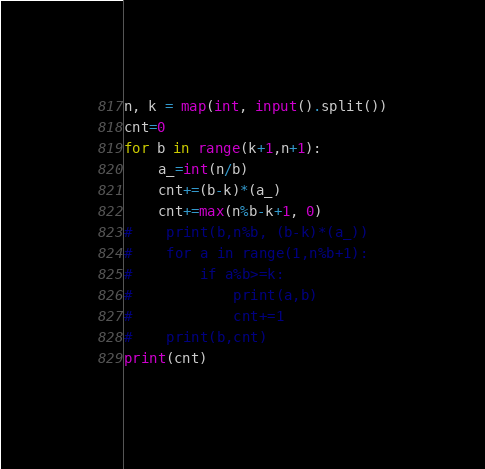<code> <loc_0><loc_0><loc_500><loc_500><_Python_>n, k = map(int, input().split())
cnt=0
for b in range(k+1,n+1):
    a_=int(n/b)
    cnt+=(b-k)*(a_)
    cnt+=max(n%b-k+1, 0)
#    print(b,n%b, (b-k)*(a_))
#    for a in range(1,n%b+1):
#        if a%b>=k:
#            print(a,b)
#            cnt+=1
#    print(b,cnt)
print(cnt)
</code> 